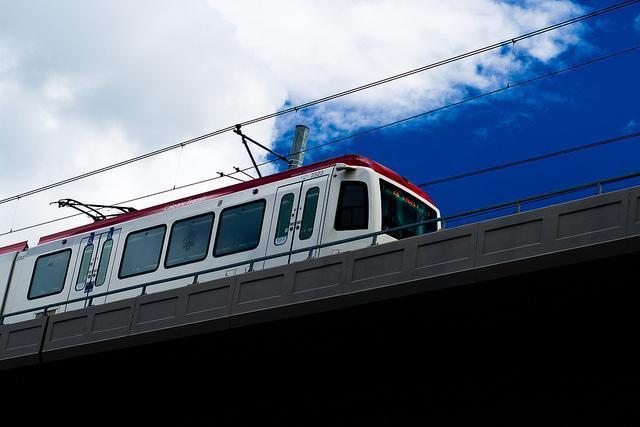How many windows on the train?
Give a very brief answer. 10. 